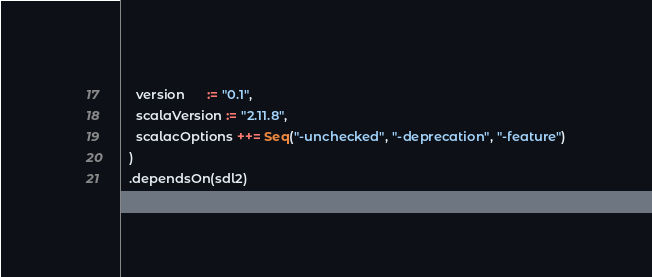Convert code to text. <code><loc_0><loc_0><loc_500><loc_500><_Scala_>    version      := "0.1",
    scalaVersion := "2.11.8",
    scalacOptions ++= Seq("-unchecked", "-deprecation", "-feature")
  )
  .dependsOn(sdl2)
</code> 